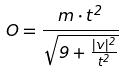<formula> <loc_0><loc_0><loc_500><loc_500>O = \frac { m \cdot t ^ { 2 } } { \sqrt { 9 + \frac { | v | ^ { 2 } } { t ^ { 2 } } } }</formula> 